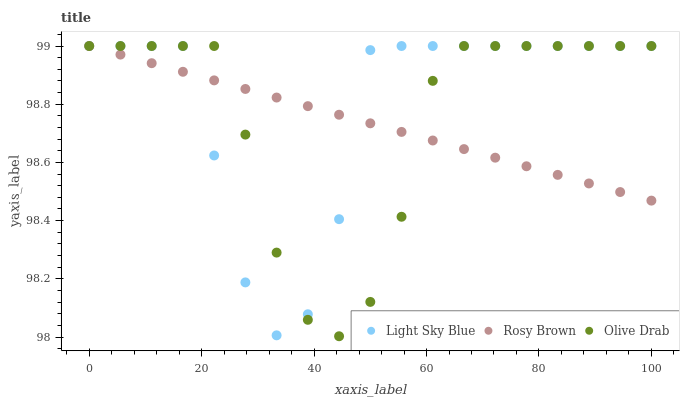Does Rosy Brown have the minimum area under the curve?
Answer yes or no. Yes. Does Light Sky Blue have the maximum area under the curve?
Answer yes or no. Yes. Does Olive Drab have the minimum area under the curve?
Answer yes or no. No. Does Olive Drab have the maximum area under the curve?
Answer yes or no. No. Is Rosy Brown the smoothest?
Answer yes or no. Yes. Is Light Sky Blue the roughest?
Answer yes or no. Yes. Is Olive Drab the smoothest?
Answer yes or no. No. Is Olive Drab the roughest?
Answer yes or no. No. Does Olive Drab have the lowest value?
Answer yes or no. Yes. Does Light Sky Blue have the lowest value?
Answer yes or no. No. Does Olive Drab have the highest value?
Answer yes or no. Yes. Does Light Sky Blue intersect Olive Drab?
Answer yes or no. Yes. Is Light Sky Blue less than Olive Drab?
Answer yes or no. No. Is Light Sky Blue greater than Olive Drab?
Answer yes or no. No. 